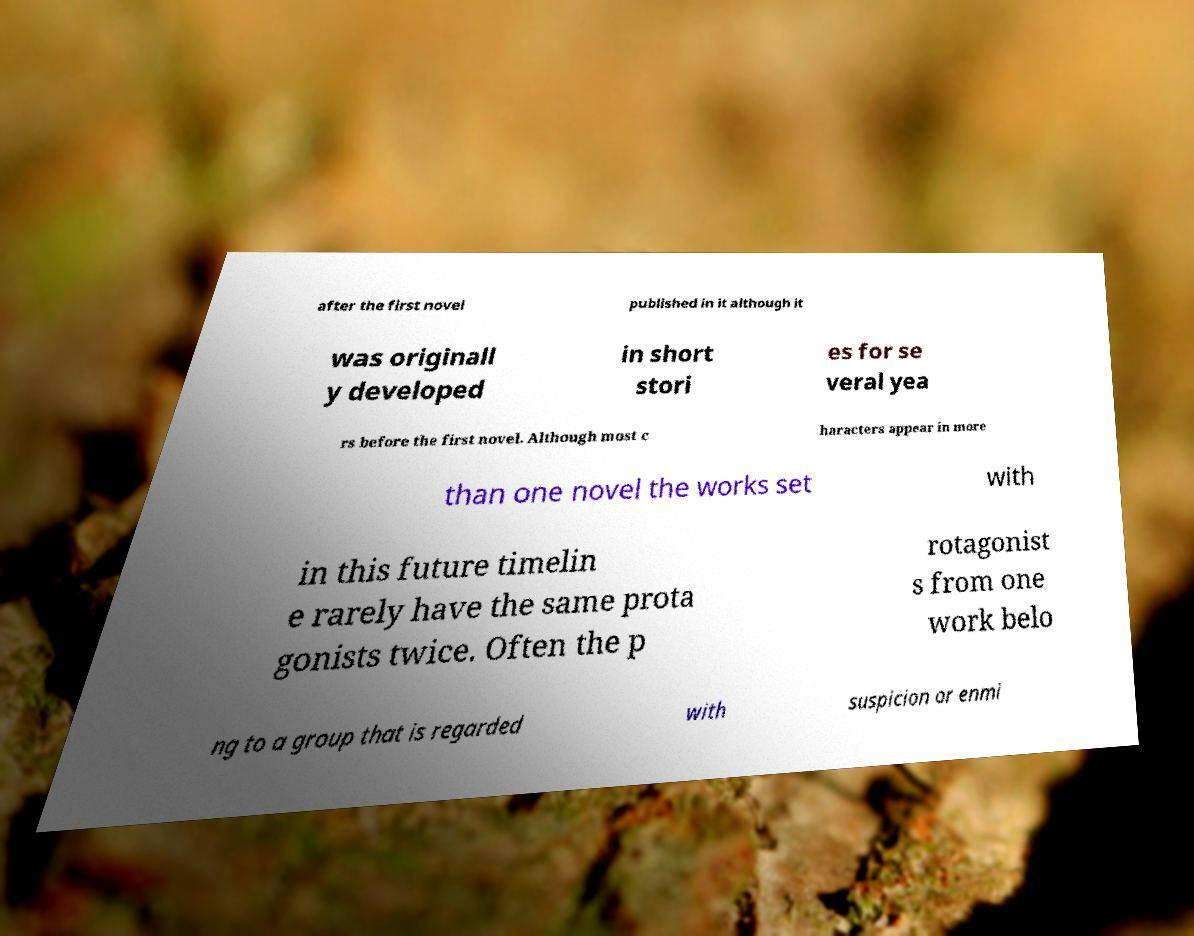Could you assist in decoding the text presented in this image and type it out clearly? after the first novel published in it although it was originall y developed in short stori es for se veral yea rs before the first novel. Although most c haracters appear in more than one novel the works set with in this future timelin e rarely have the same prota gonists twice. Often the p rotagonist s from one work belo ng to a group that is regarded with suspicion or enmi 